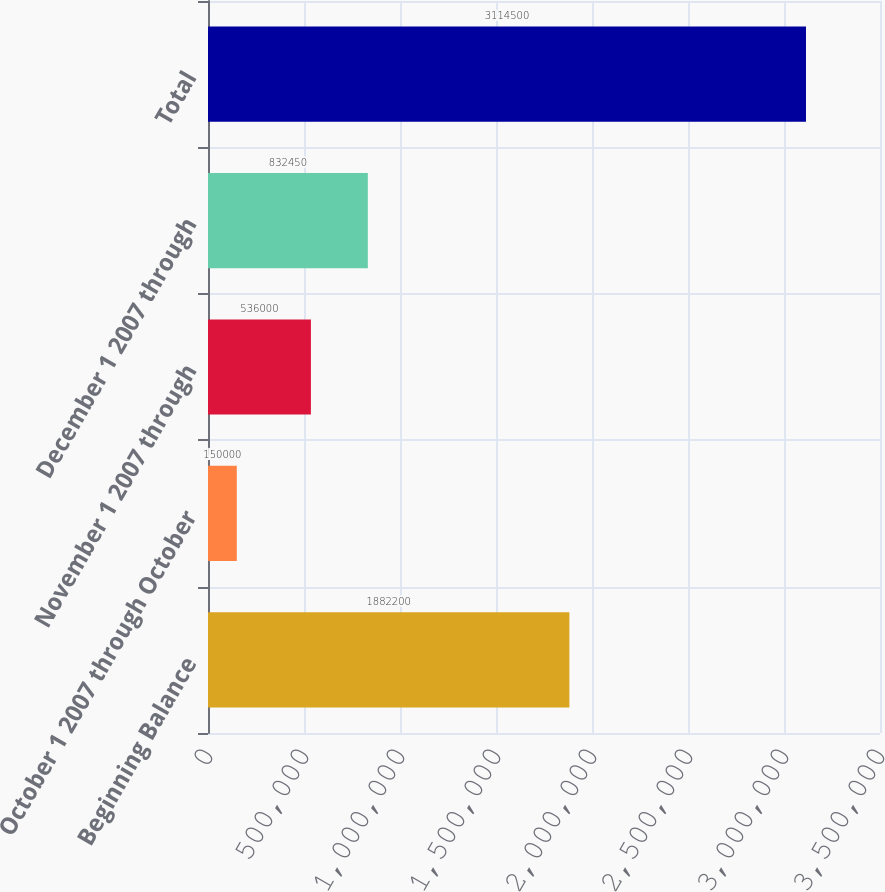<chart> <loc_0><loc_0><loc_500><loc_500><bar_chart><fcel>Beginning Balance<fcel>October 1 2007 through October<fcel>November 1 2007 through<fcel>December 1 2007 through<fcel>Total<nl><fcel>1.8822e+06<fcel>150000<fcel>536000<fcel>832450<fcel>3.1145e+06<nl></chart> 